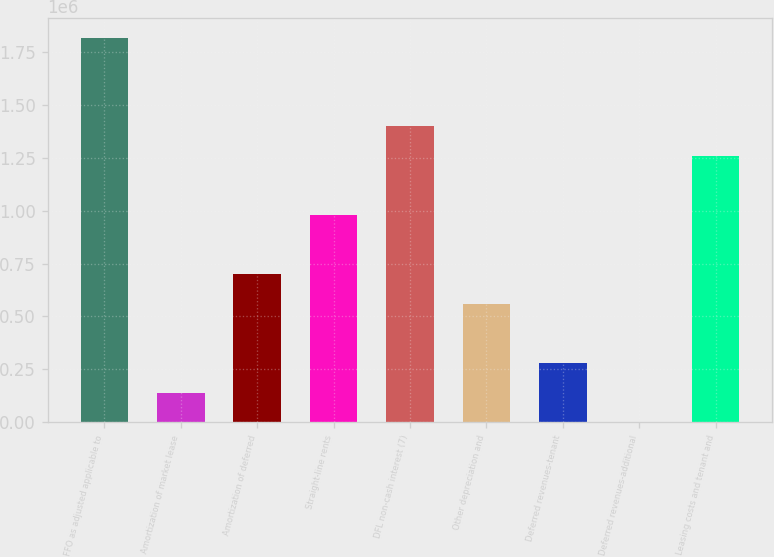Convert chart. <chart><loc_0><loc_0><loc_500><loc_500><bar_chart><fcel>FFO as adjusted applicable to<fcel>Amortization of market lease<fcel>Amortization of deferred<fcel>Straight-line rents<fcel>DFL non-cash interest (7)<fcel>Other depreciation and<fcel>Deferred revenues-tenant<fcel>Deferred revenues-additional<fcel>Leasing costs and tenant and<nl><fcel>1.81817e+06<fcel>140249<fcel>699556<fcel>979210<fcel>1.39869e+06<fcel>559730<fcel>280076<fcel>422<fcel>1.25886e+06<nl></chart> 